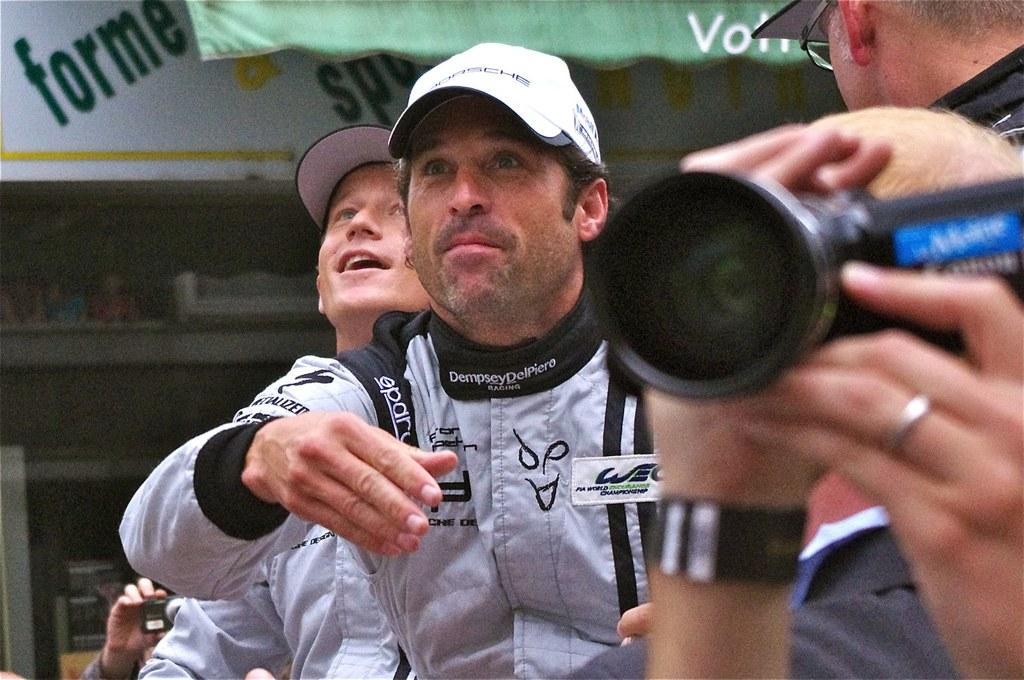Could you give a brief overview of what you see in this image? In this image right side hands are visible ,holding a camera on the hand and wearing a band and wearing a ring. Back side of the hand man standing and wearing a black colour jacket,back side of the black colour jacket person a man standing and wearing a spectacles. In front of him there is a sign board ,on the sign board there is some text written on that. In the center of the image there is a person wearing a cap ,back side of the wearing a gray colour jacket and wearing a cap and his smiling. On the bottom left a hand is visible with holding camera. 